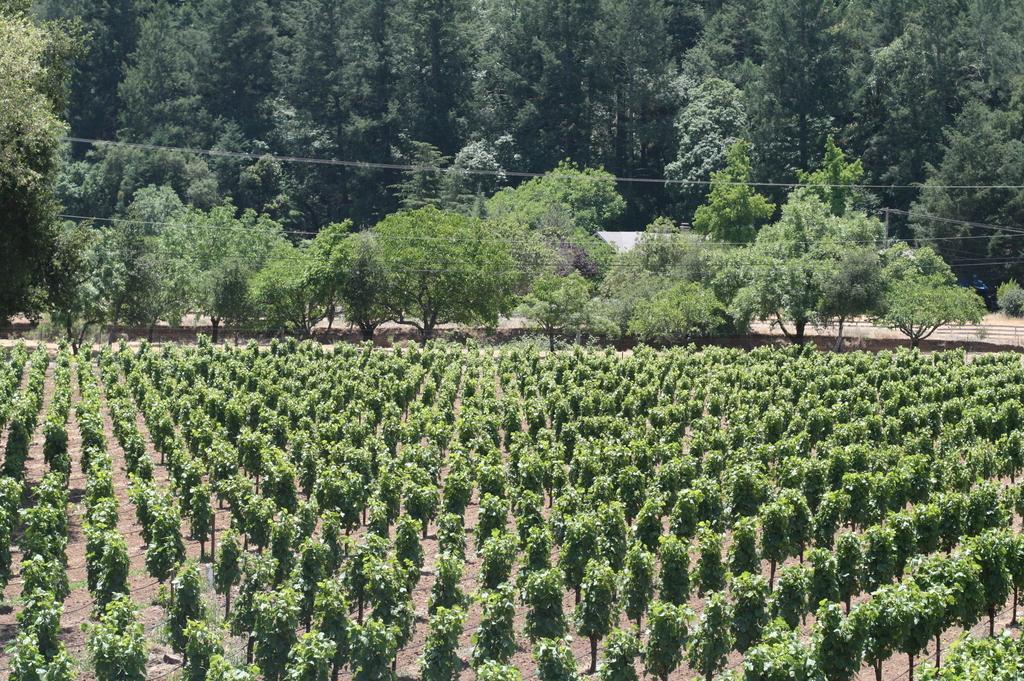Describe this image in one or two sentences. In the image there is a field and behind the field there are plenty of trees. 